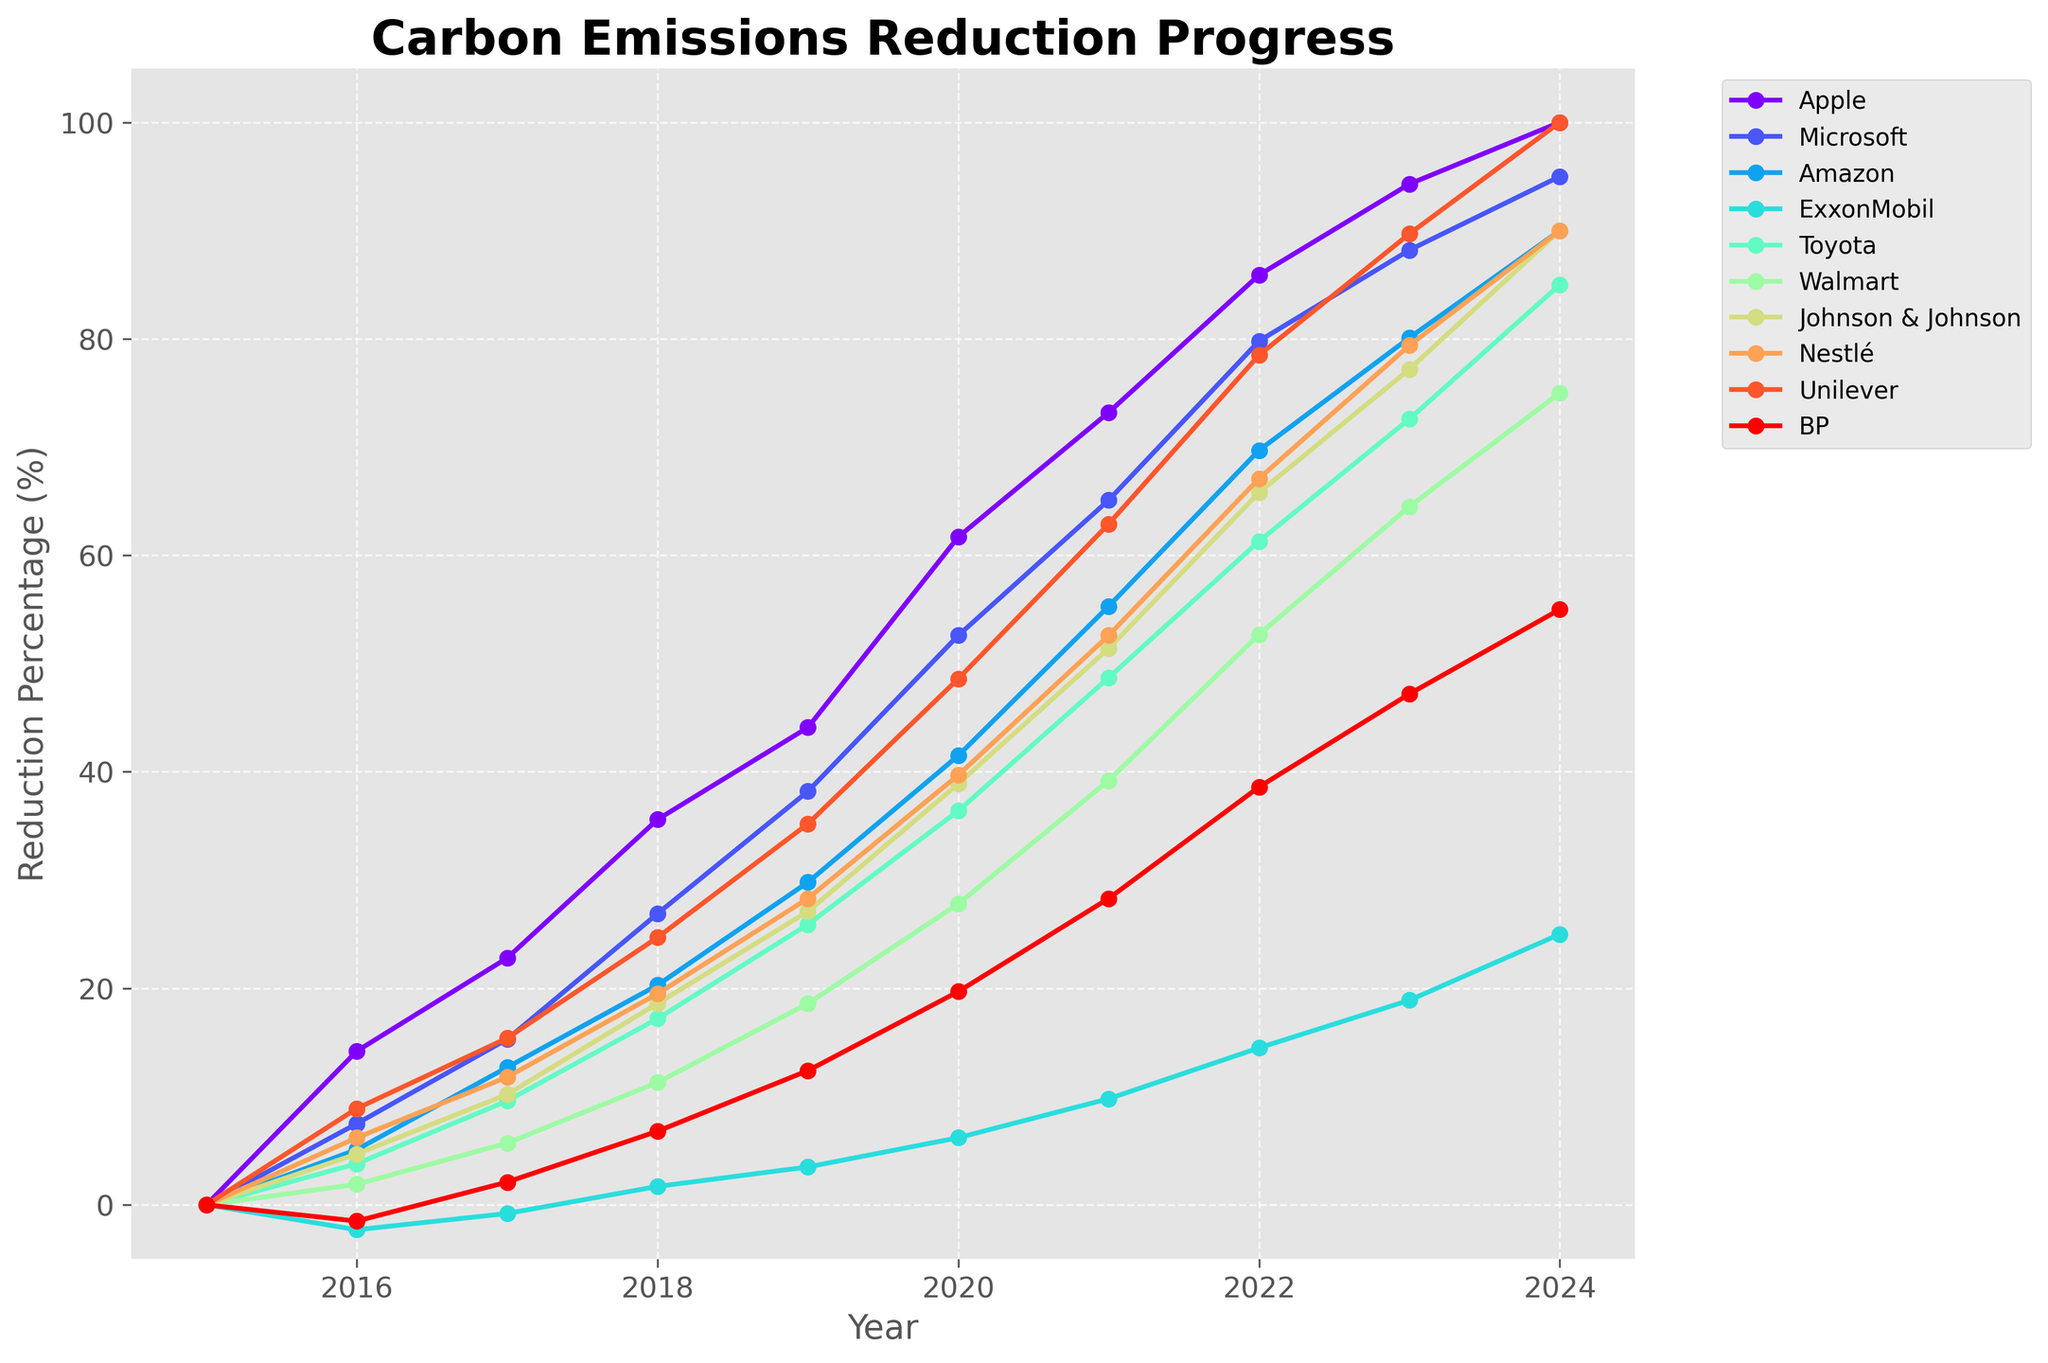What was Nestlé's reduction percentage in 2016 compared to 2022? Subtract Nestlé's reduction in 2016 (6.2%) from its reduction in 2022 (67.1%). The calculation is 67.1% - 6.2% = 60.9%.
Answer: 60.9% Did any company have a negative reduction in any year? If so, which companies and when? By examining the chart, we can see that ExxonMobil had negative values in 2016 (-2.3%) and BP had a negative value in 2016 (-1.5%).
Answer: ExxonMobil (2016) and BP (2016) Which company's reduction percentage increased the most from 2015 to 2024? To find this, we need to calculate the difference between 2024 and 2015 values for each company. Apple: 100-0=100, Microsoft: 95-0=95, Amazon: 90-0=90, ExxonMobil: 25-0=25, Toyota: 85-0=85, Walmart: 75-0=75, Johnson & Johnson: 90-0=90, Nestlé: 90-0=90, Unilever: 100-0=100, BP: 55-0=55. The highest increase is for Apple and Unilever, both with a 100% increase.
Answer: Apple and Unilever In what year did Apple first surpass a reduction of 50%? By looking at Apple's data, we see that 61.7% was achieved in 2020, which is the first year Apple surpassed 50%.
Answer: 2020 Compare the reduction progress of Toyota and BP in 2021. Which company achieved a higher reduction? In 2021, Toyota had a reduction of 48.7% and BP had a reduction of 28.3%. Therefore, Toyota had a higher reduction.
Answer: Toyota What is the average reduction percentage achieved by Walmart from 2015 to 2024? Sum Walmart's reduction percentages from 2015 to 2024: 0+1.9+5.7+11.3+18.6+27.8+39.2+52.7+64.5+75 = 297.7. Divide by the number of years (10): 297.7 / 10 = 29.77%.
Answer: 29.77% How many companies reached a reduction of 90% by 2024? From the chart, Apple, Amazon, Johnson & Johnson, Nestlé, and Unilever each had a reduction of 90% or more by 2024. This totals to five companies.
Answer: 5 What was the reduction trend for BP from 2016 to 2020? BP's reduction percentages were -1.5%, 2.1%, 6.8%, 12.4%, and 19.7% from 2016 to 2020, respectively. This shows a steadily increasing trend in reduction over these years.
Answer: Increasing Which company had the smallest reduction in 2023? By looking at the data for 2023, ExxonMobil had the smallest reduction at 18.9%.
Answer: ExxonMobil How did the reduction percentage of Johnson & Johnson in 2020 compare to its reduction percentage in 2018? Subtract Johnson & Johnson's reduction in 2018 (18.6%) from its reduction in 2020 (38.9%). The calculation is 38.9% - 18.6% = 20.3%.
Answer: Increased by 20.3% 